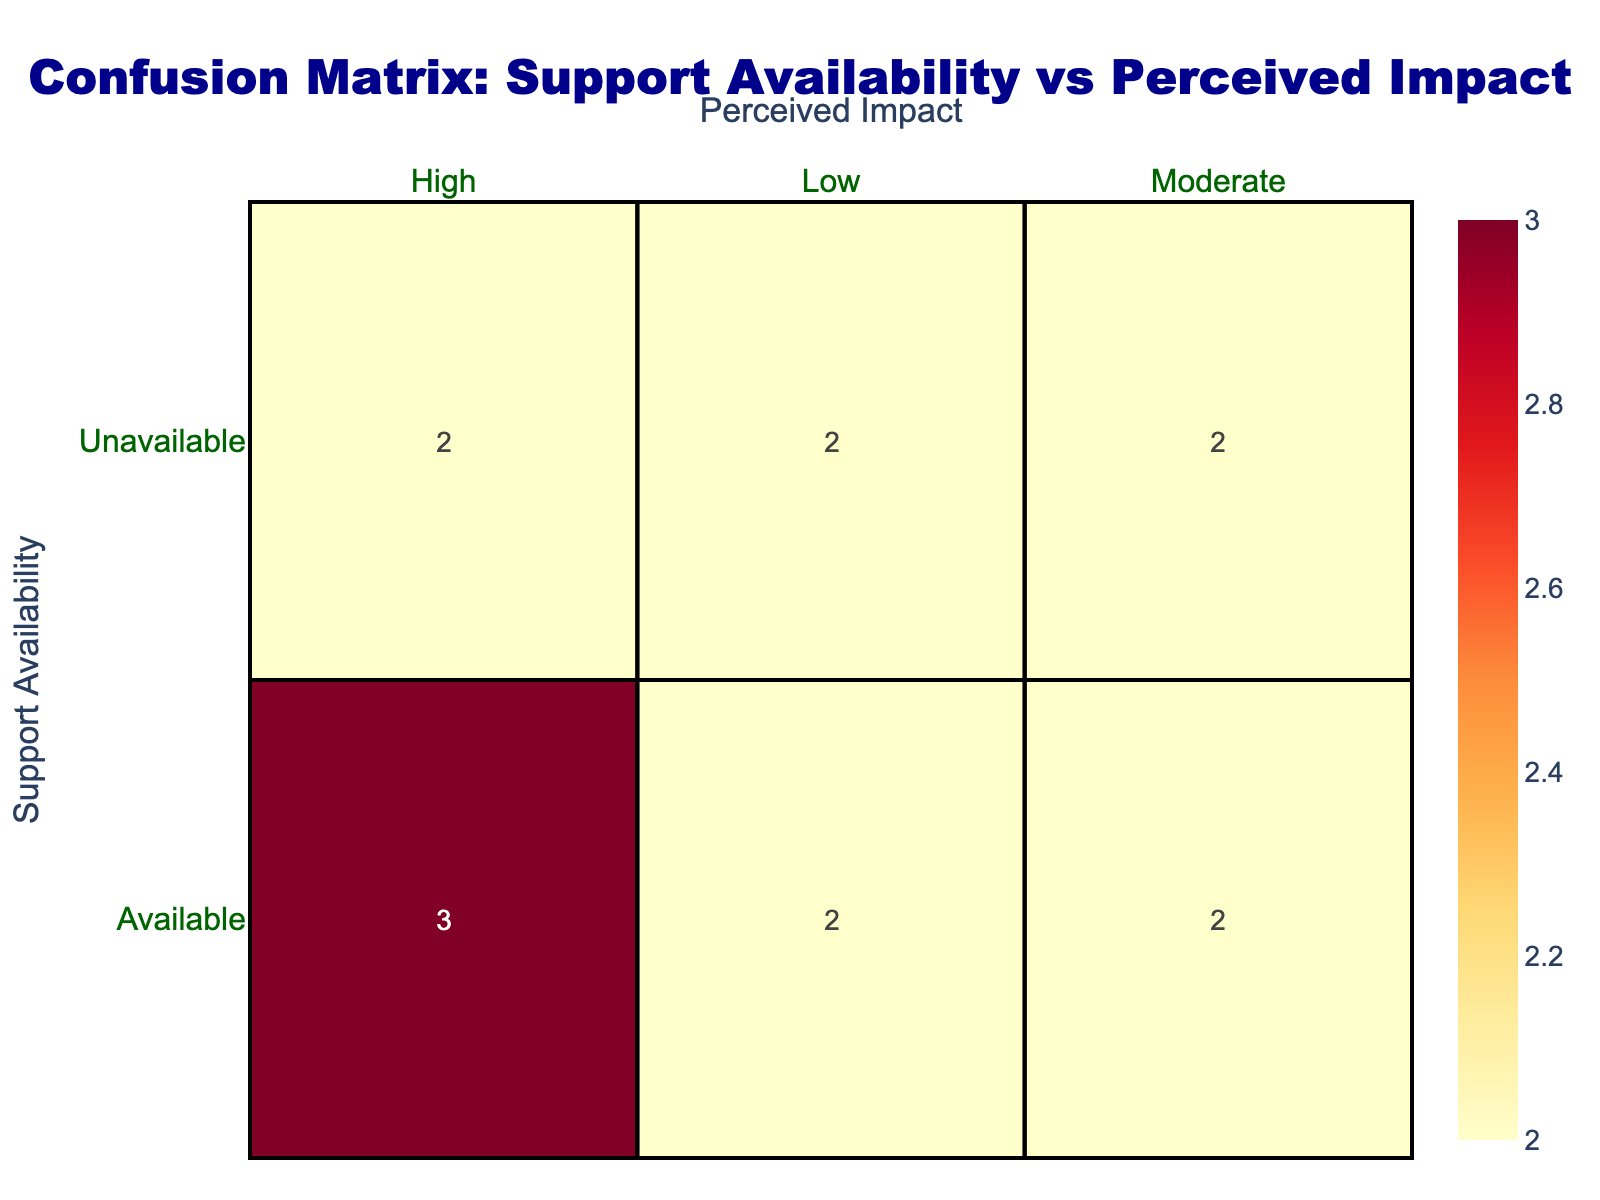What is the total count of police officers who perceived the impact as High? In the table, we look for the rows where the perceived impact is High. We see two instances where support availability is Available and two instances where it is Unavailable. Thus, we have a total of 2 (Available) + 2 (Unavailable) = 4.
Answer: 4 What is the total count of officers where support was available? To find this out, we need to examine the table and count the rows under the 'Available' category for support availability. There are 6 rows where support is Available.
Answer: 6 What is the percentage of officers who perceived the impact as Low with Unavailable support? To find the percentage, we first identify the count of officers who perceived the impact as Low and had Unavailable support, which is 3. The total count under Unavailable is 4 (2 High, 1 Moderate, 1 Low). Therefore, the percentage is (1/4) * 100 = 25%.
Answer: 25% Is there a higher count of officers perceiving Moderate impact when support is Available or Unavailable? Looking at the table, there are 3 instances of Moderate impact when support is Available and 2 when support is Unavailable. Since 3 is greater than 2, the answer is that there is a higher count when support is Available.
Answer: Yes What is the difference in counts between Available support for High impact and Unavailable support for High impact? We first count the instances of High impact with Available support, which is 4, and with Unavailable support, which is 2. The difference is calculated as 4 (Available) - 2 (Unavailable) = 2.
Answer: 2 What is the average perceived impact count for officers with Available support? To find the average, we need to sum the counts for High (4), Moderate (3), and Low (2) with Available support. This gives us a total of 4 + 3 + 2 = 9. Since there are 3 categories, we divide by 3 to get the average, which is 9/3 = 3.
Answer: 3 How many officers perceived a High impact when support was unavailable? From the table, we find that there are 2 instances where the perceived impact is High with Unavailable support.
Answer: 2 Is it true that more police officers perceived a Moderate impact than a Low impact when support was Available? By checking the counts, we have 3 for Moderate impact and 2 for Low impact under Available support. Since 3 is greater than 2, it is true.
Answer: Yes 